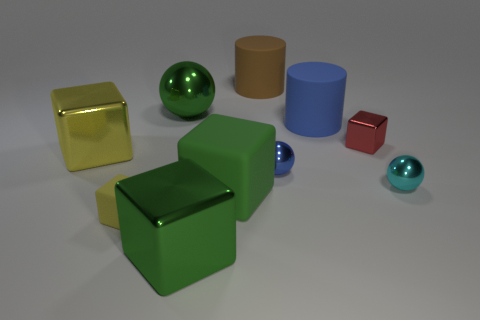Subtract all red cubes. How many cubes are left? 4 Subtract all large yellow metallic blocks. How many blocks are left? 4 Subtract all blue cubes. Subtract all yellow balls. How many cubes are left? 5 Subtract all cylinders. How many objects are left? 8 Subtract all yellow objects. Subtract all red metal cubes. How many objects are left? 7 Add 2 matte objects. How many matte objects are left? 6 Add 4 small balls. How many small balls exist? 6 Subtract 1 red cubes. How many objects are left? 9 